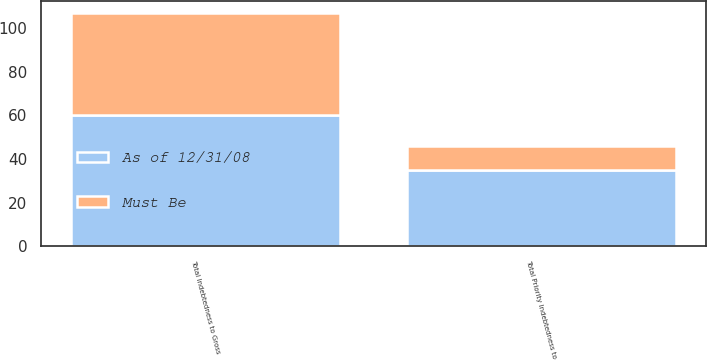Convert chart. <chart><loc_0><loc_0><loc_500><loc_500><stacked_bar_chart><ecel><fcel>Total Indebtedness to Gross<fcel>Total Priority Indebtedness to<nl><fcel>As of 12/31/08<fcel>60<fcel>35<nl><fcel>Must Be<fcel>47<fcel>11<nl></chart> 